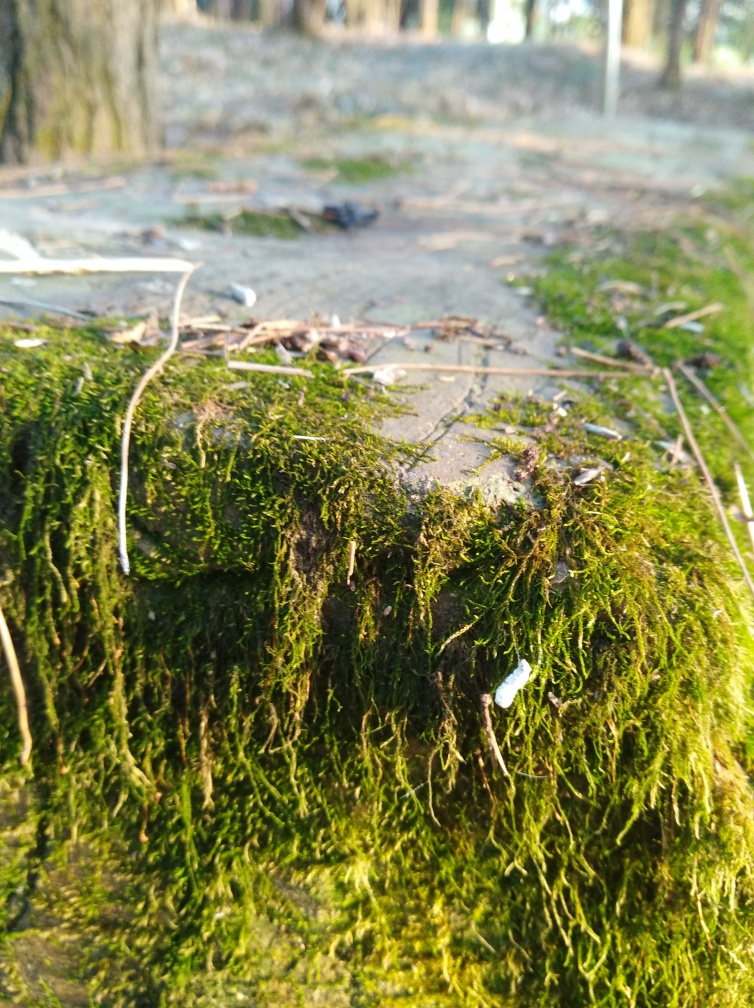Might there be any wildlife present in this type of setting? A moss-covered environment like the one shown is often home to a diverse range of small wildlife, including insects like beetles and spiders, as well as amphibians such as frogs and salamanders. The rich microhabitat provides shelter and food for these creatures, making it a critical part of the broader ecosystem. 